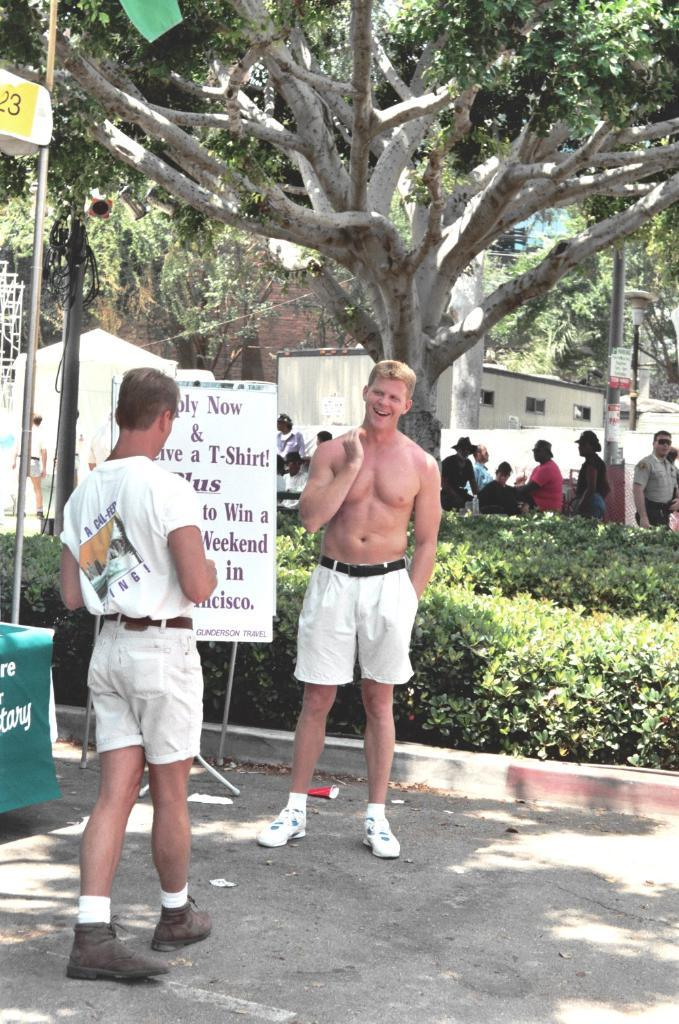Provide a one-sentence caption for the provided image. Two men are standing by a sign that says Apply Now. 